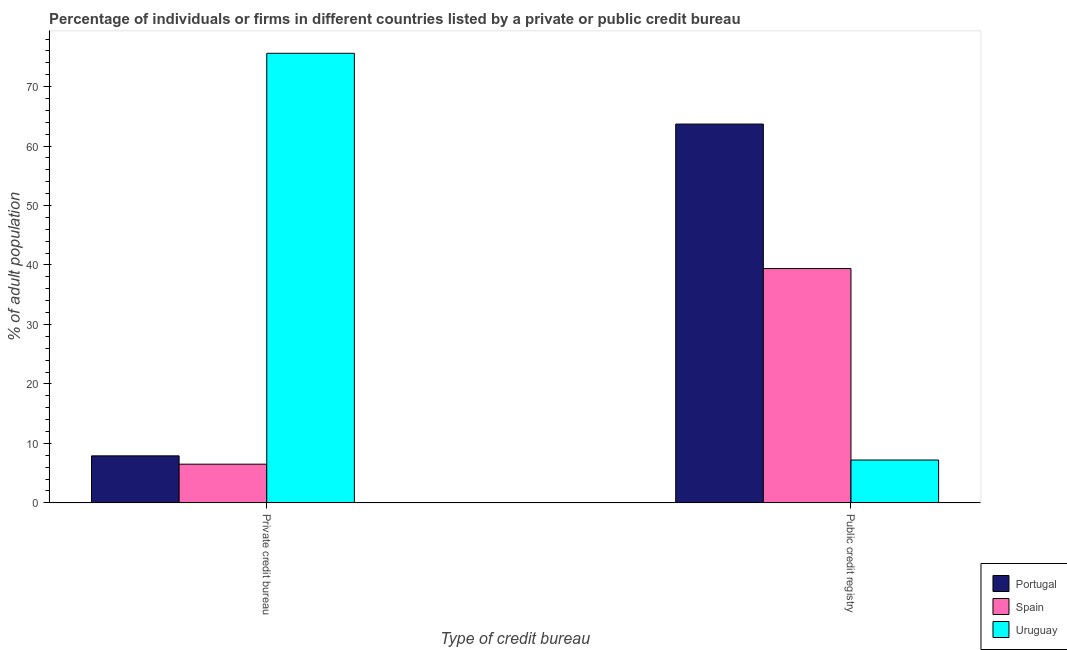How many different coloured bars are there?
Give a very brief answer. 3. How many groups of bars are there?
Provide a short and direct response. 2. Are the number of bars on each tick of the X-axis equal?
Provide a short and direct response. Yes. What is the label of the 1st group of bars from the left?
Offer a very short reply. Private credit bureau. Across all countries, what is the maximum percentage of firms listed by public credit bureau?
Offer a terse response. 63.7. In which country was the percentage of firms listed by private credit bureau maximum?
Provide a succinct answer. Uruguay. In which country was the percentage of firms listed by private credit bureau minimum?
Your answer should be compact. Spain. What is the difference between the percentage of firms listed by private credit bureau in Uruguay and that in Portugal?
Offer a terse response. 67.7. What is the difference between the percentage of firms listed by private credit bureau in Spain and the percentage of firms listed by public credit bureau in Uruguay?
Keep it short and to the point. -0.7. What is the difference between the percentage of firms listed by private credit bureau and percentage of firms listed by public credit bureau in Spain?
Make the answer very short. -32.9. In how many countries, is the percentage of firms listed by private credit bureau greater than 64 %?
Provide a succinct answer. 1. What is the ratio of the percentage of firms listed by private credit bureau in Portugal to that in Spain?
Offer a terse response. 1.22. In how many countries, is the percentage of firms listed by private credit bureau greater than the average percentage of firms listed by private credit bureau taken over all countries?
Ensure brevity in your answer.  1. What does the 2nd bar from the left in Public credit registry represents?
Make the answer very short. Spain. What does the 1st bar from the right in Public credit registry represents?
Provide a succinct answer. Uruguay. Are all the bars in the graph horizontal?
Offer a very short reply. No. How many countries are there in the graph?
Offer a terse response. 3. What is the difference between two consecutive major ticks on the Y-axis?
Your answer should be compact. 10. Are the values on the major ticks of Y-axis written in scientific E-notation?
Your answer should be compact. No. Does the graph contain grids?
Provide a succinct answer. No. Where does the legend appear in the graph?
Keep it short and to the point. Bottom right. How many legend labels are there?
Your answer should be very brief. 3. What is the title of the graph?
Your response must be concise. Percentage of individuals or firms in different countries listed by a private or public credit bureau. What is the label or title of the X-axis?
Make the answer very short. Type of credit bureau. What is the label or title of the Y-axis?
Give a very brief answer. % of adult population. What is the % of adult population in Uruguay in Private credit bureau?
Provide a succinct answer. 75.6. What is the % of adult population of Portugal in Public credit registry?
Make the answer very short. 63.7. What is the % of adult population in Spain in Public credit registry?
Your answer should be compact. 39.4. What is the % of adult population of Uruguay in Public credit registry?
Offer a very short reply. 7.2. Across all Type of credit bureau, what is the maximum % of adult population in Portugal?
Provide a succinct answer. 63.7. Across all Type of credit bureau, what is the maximum % of adult population in Spain?
Your response must be concise. 39.4. Across all Type of credit bureau, what is the maximum % of adult population in Uruguay?
Provide a succinct answer. 75.6. Across all Type of credit bureau, what is the minimum % of adult population in Spain?
Your answer should be very brief. 6.5. What is the total % of adult population of Portugal in the graph?
Ensure brevity in your answer.  71.6. What is the total % of adult population of Spain in the graph?
Keep it short and to the point. 45.9. What is the total % of adult population in Uruguay in the graph?
Your answer should be very brief. 82.8. What is the difference between the % of adult population in Portugal in Private credit bureau and that in Public credit registry?
Provide a short and direct response. -55.8. What is the difference between the % of adult population in Spain in Private credit bureau and that in Public credit registry?
Give a very brief answer. -32.9. What is the difference between the % of adult population in Uruguay in Private credit bureau and that in Public credit registry?
Provide a succinct answer. 68.4. What is the difference between the % of adult population of Portugal in Private credit bureau and the % of adult population of Spain in Public credit registry?
Ensure brevity in your answer.  -31.5. What is the difference between the % of adult population of Portugal in Private credit bureau and the % of adult population of Uruguay in Public credit registry?
Keep it short and to the point. 0.7. What is the average % of adult population of Portugal per Type of credit bureau?
Offer a very short reply. 35.8. What is the average % of adult population in Spain per Type of credit bureau?
Offer a very short reply. 22.95. What is the average % of adult population in Uruguay per Type of credit bureau?
Keep it short and to the point. 41.4. What is the difference between the % of adult population of Portugal and % of adult population of Spain in Private credit bureau?
Provide a succinct answer. 1.4. What is the difference between the % of adult population in Portugal and % of adult population in Uruguay in Private credit bureau?
Your response must be concise. -67.7. What is the difference between the % of adult population in Spain and % of adult population in Uruguay in Private credit bureau?
Offer a terse response. -69.1. What is the difference between the % of adult population of Portugal and % of adult population of Spain in Public credit registry?
Make the answer very short. 24.3. What is the difference between the % of adult population in Portugal and % of adult population in Uruguay in Public credit registry?
Give a very brief answer. 56.5. What is the difference between the % of adult population in Spain and % of adult population in Uruguay in Public credit registry?
Offer a very short reply. 32.2. What is the ratio of the % of adult population in Portugal in Private credit bureau to that in Public credit registry?
Give a very brief answer. 0.12. What is the ratio of the % of adult population in Spain in Private credit bureau to that in Public credit registry?
Offer a terse response. 0.17. What is the ratio of the % of adult population in Uruguay in Private credit bureau to that in Public credit registry?
Keep it short and to the point. 10.5. What is the difference between the highest and the second highest % of adult population in Portugal?
Your response must be concise. 55.8. What is the difference between the highest and the second highest % of adult population in Spain?
Ensure brevity in your answer.  32.9. What is the difference between the highest and the second highest % of adult population in Uruguay?
Give a very brief answer. 68.4. What is the difference between the highest and the lowest % of adult population of Portugal?
Your response must be concise. 55.8. What is the difference between the highest and the lowest % of adult population of Spain?
Offer a very short reply. 32.9. What is the difference between the highest and the lowest % of adult population in Uruguay?
Offer a very short reply. 68.4. 